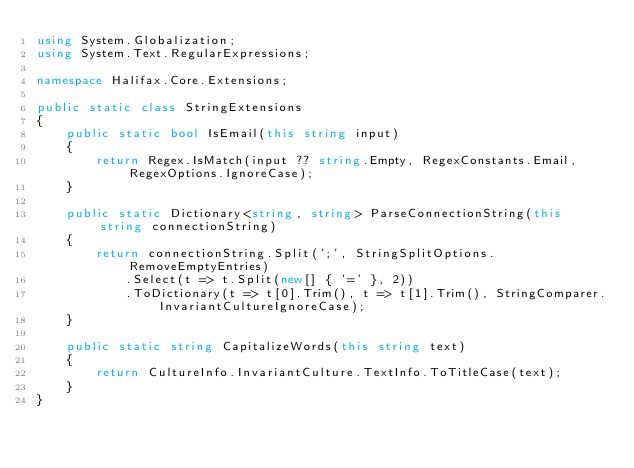<code> <loc_0><loc_0><loc_500><loc_500><_C#_>using System.Globalization;
using System.Text.RegularExpressions;

namespace Halifax.Core.Extensions;

public static class StringExtensions
{
    public static bool IsEmail(this string input)
    {
        return Regex.IsMatch(input ?? string.Empty, RegexConstants.Email, RegexOptions.IgnoreCase);
    }

    public static Dictionary<string, string> ParseConnectionString(this string connectionString)
    {
        return connectionString.Split(';', StringSplitOptions.RemoveEmptyEntries)
            .Select(t => t.Split(new[] { '=' }, 2))
            .ToDictionary(t => t[0].Trim(), t => t[1].Trim(), StringComparer.InvariantCultureIgnoreCase);
    }

    public static string CapitalizeWords(this string text)
    {
        return CultureInfo.InvariantCulture.TextInfo.ToTitleCase(text);
    }
}
</code> 